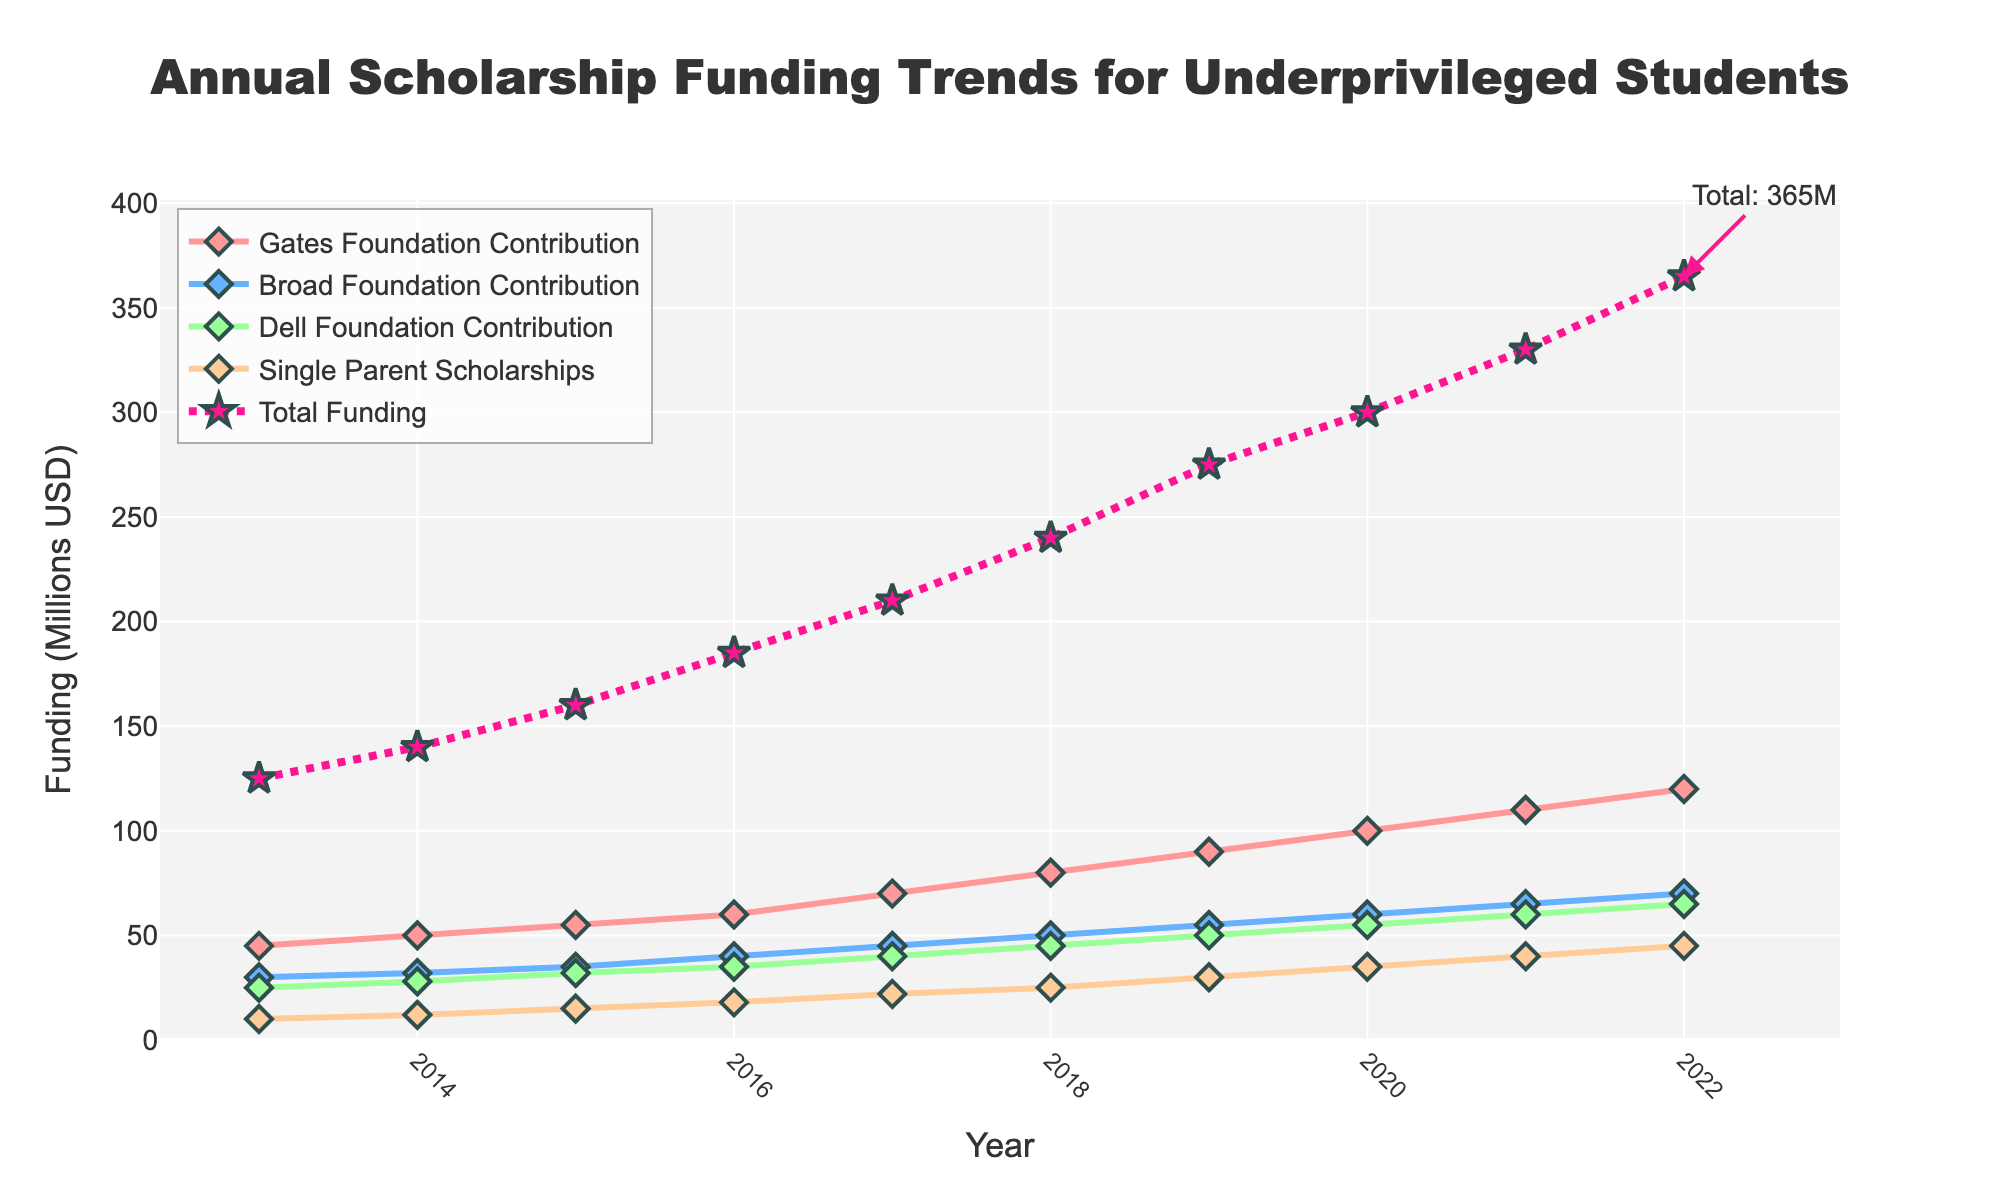How much total funding was provided for underprivileged students in 2019? The total funding for each year is indicated by the data points along the "Total Funding" line, marked by stars. In 2019, the data point corresponding to "Total Funding" shows a value of 275 million USD.
Answer: 275 million USD What was the difference in total funding between 2020 and 2022? The total funding for 2020 is 300 million USD and for 2022 is 365 million USD. The difference can be calculated by subtracting the 2020 value from the 2022 value: 365 - 300 = 65 million USD.
Answer: 65 million USD Which foundation contributed the most to total funding in 2021? By comparing the lines for each foundation, one can see that the "Gates Foundation Contribution" line is the highest in 2021. The Gates Foundation contributed 110 million USD in 2021.
Answer: Gates Foundation How did funding for Single Parent Scholarships change from 2015 to 2016? The funding for Single Parent Scholarships in 2015 is 15 million USD and in 2016 is 18 million USD. The change is calculated as 18 - 15 = 3 million USD.
Answer: Increased by 3 million USD Which year saw the highest increase in total funding compared to the previous year? To find the largest year-to-year increase, compare the differences in total funding between consecutive years. The increases are: 2014-2013: 15M, 2015-2014: 20M, 2016-2015: 25M, 2017-2016: 25M, 2018-2017: 30M, 2019-2018: 35M, 2020-2019: 25M, 2021-2020: 30M, 2022-2021: 35M. The largest increase was in 2019-2018 and 2022-2021 with a 35 million USD increase.
Answer: 2019 and 2022 What is the total funding amount from the Dell Foundation in 2020? Observing the "Dell Foundation Contribution" line, the data point for 2020 shows a value of 55 million USD.
Answer: 55 million USD How much more did the Gates Foundation contribute in 2022 compared to the Broad Foundation? In 2022, the Gates Foundation contributed 120 million USD, while the Broad Foundation contributed 70 million USD. The difference is 120 - 70 = 50 million USD.
Answer: 50 million USD What is the average annual funding for Single Parent Scholarships over the decade? The Single Parent Scholarships funding for each year from 2013 to 2022 are: 10, 12, 15, 18, 22, 25, 30, 35, 40, 45 million USD. Sum these values to get 252 million USD. The average is then 252 / 10 = 25.2 million USD.
Answer: 25.2 million USD Which year did the Broad Foundation contribute the least amount of funding? By looking at the "Broad Foundation Contribution" line, the contribution was lowest in 2013 with a value of 30 million USD.
Answer: 2013 